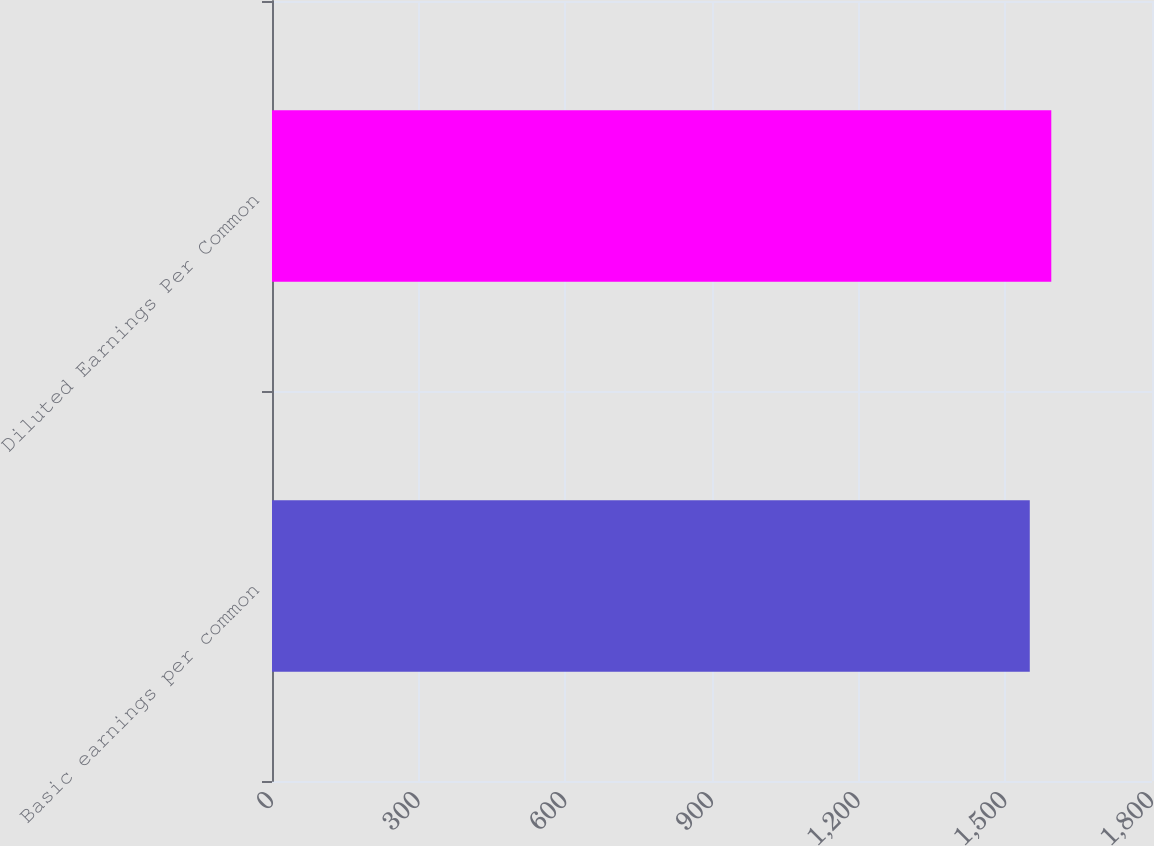Convert chart to OTSL. <chart><loc_0><loc_0><loc_500><loc_500><bar_chart><fcel>Basic earnings per common<fcel>Diluted Earnings Per Common<nl><fcel>1550<fcel>1594<nl></chart> 